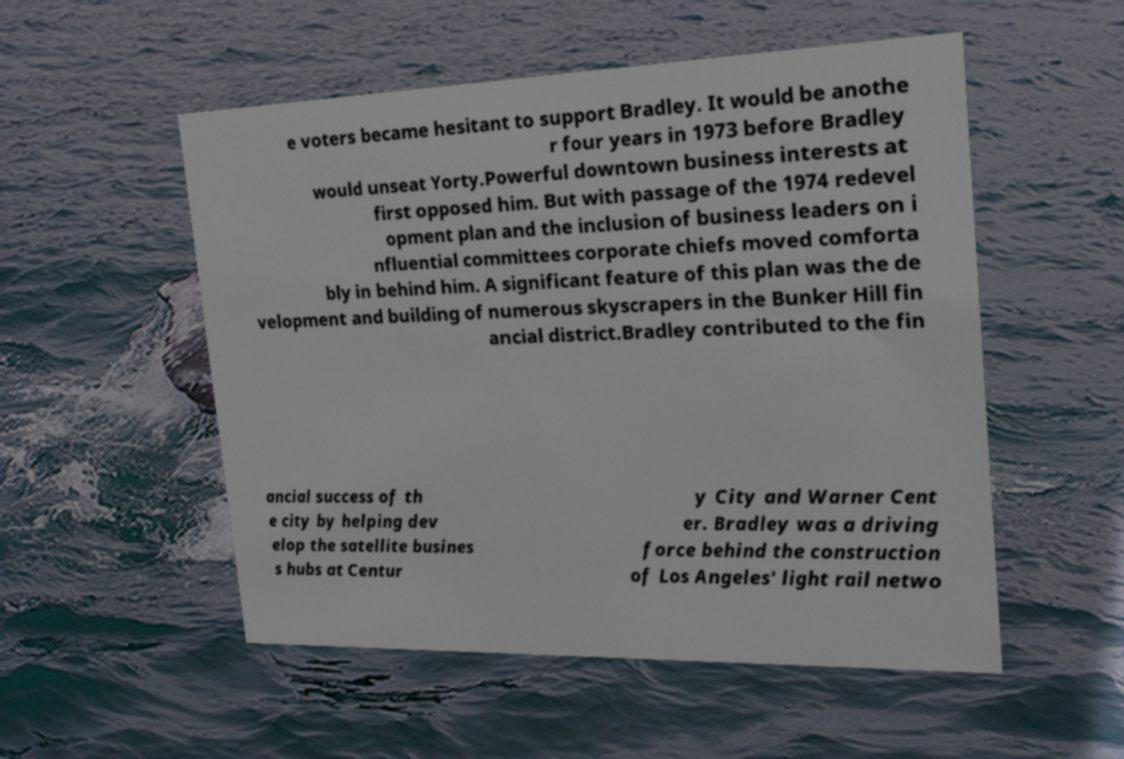Could you assist in decoding the text presented in this image and type it out clearly? e voters became hesitant to support Bradley. It would be anothe r four years in 1973 before Bradley would unseat Yorty.Powerful downtown business interests at first opposed him. But with passage of the 1974 redevel opment plan and the inclusion of business leaders on i nfluential committees corporate chiefs moved comforta bly in behind him. A significant feature of this plan was the de velopment and building of numerous skyscrapers in the Bunker Hill fin ancial district.Bradley contributed to the fin ancial success of th e city by helping dev elop the satellite busines s hubs at Centur y City and Warner Cent er. Bradley was a driving force behind the construction of Los Angeles' light rail netwo 